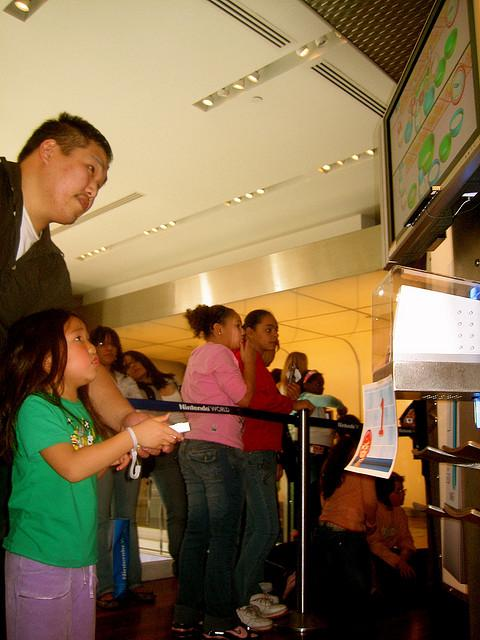What does the child hold in her hands?

Choices:
A) phone
B) jewel box
C) tv remote
D) wii remote wii remote 